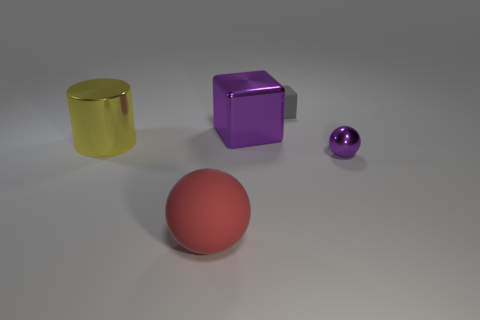Add 2 cyan rubber cubes. How many objects exist? 7 Subtract all balls. How many objects are left? 3 Subtract 1 gray blocks. How many objects are left? 4 Subtract all purple rubber things. Subtract all big blocks. How many objects are left? 4 Add 5 tiny purple objects. How many tiny purple objects are left? 6 Add 1 rubber spheres. How many rubber spheres exist? 2 